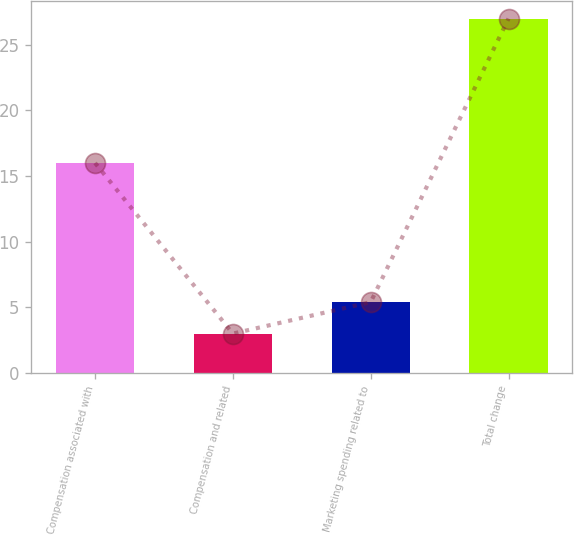Convert chart. <chart><loc_0><loc_0><loc_500><loc_500><bar_chart><fcel>Compensation associated with<fcel>Compensation and related<fcel>Marketing spending related to<fcel>Total change<nl><fcel>16<fcel>3<fcel>5.4<fcel>27<nl></chart> 